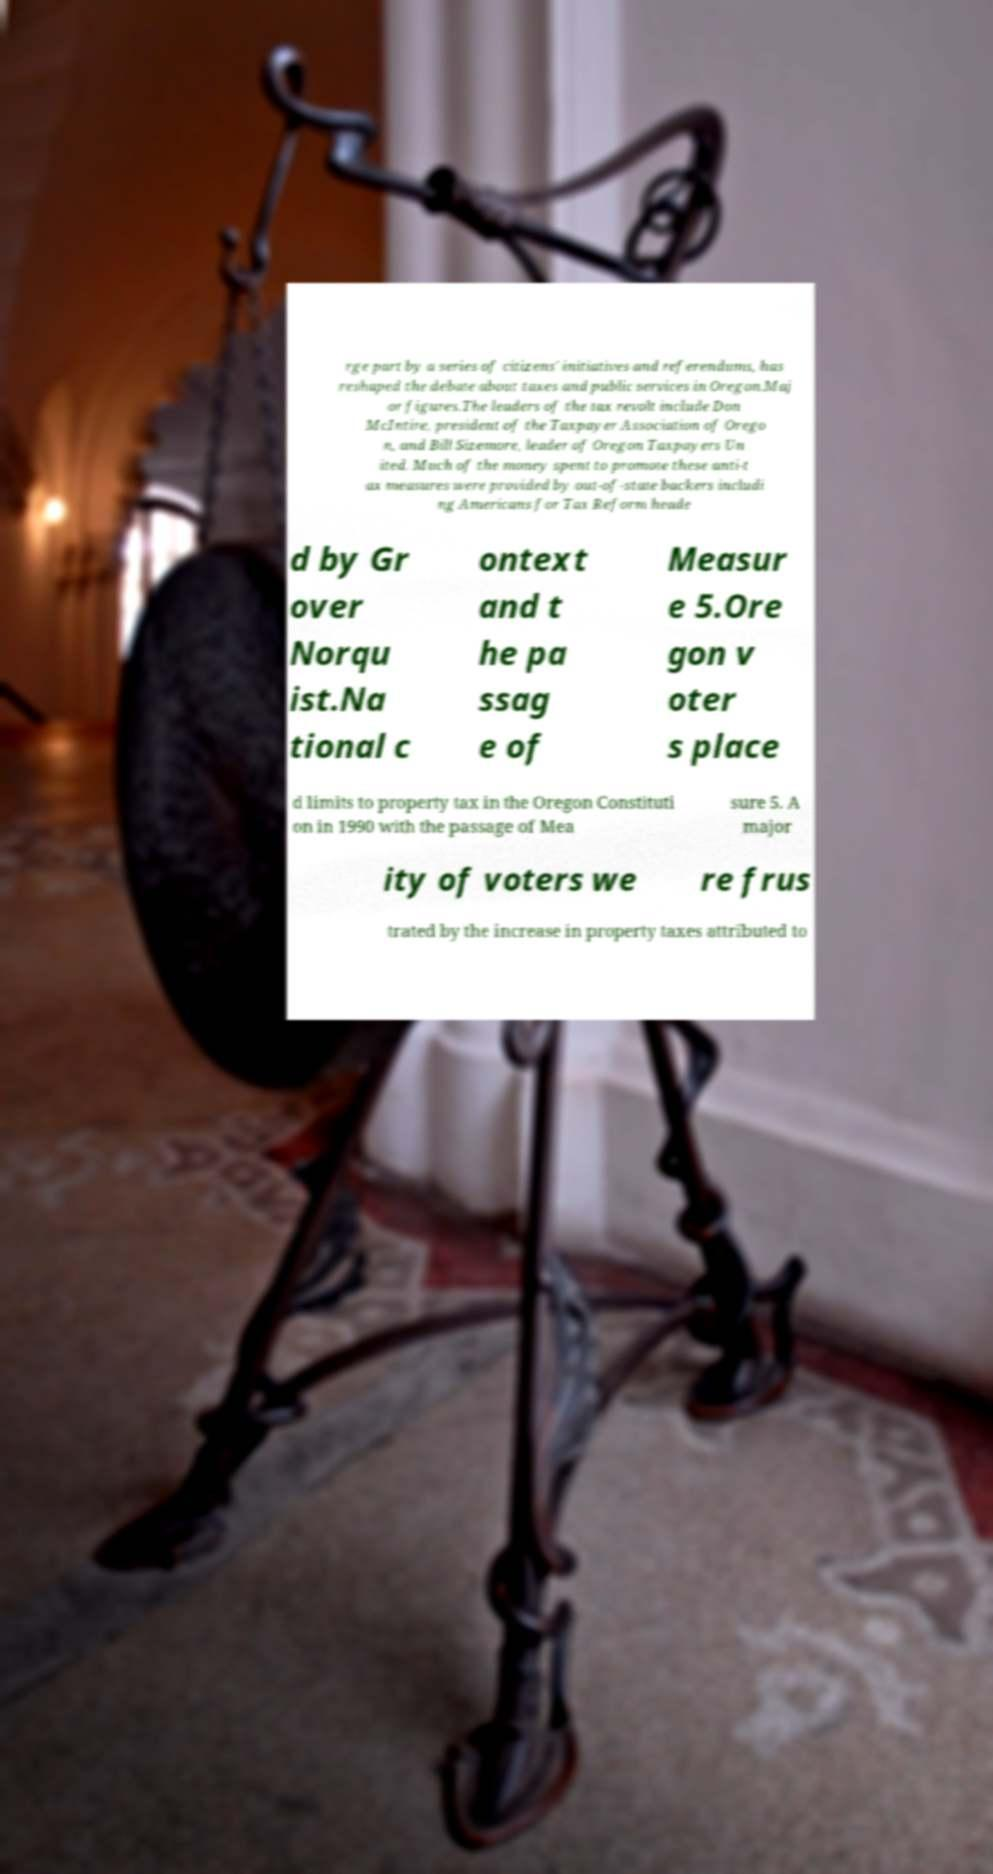Can you read and provide the text displayed in the image?This photo seems to have some interesting text. Can you extract and type it out for me? rge part by a series of citizens' initiatives and referendums, has reshaped the debate about taxes and public services in Oregon.Maj or figures.The leaders of the tax revolt include Don McIntire, president of the Taxpayer Association of Orego n, and Bill Sizemore, leader of Oregon Taxpayers Un ited. Much of the money spent to promote these anti-t ax measures were provided by out-of-state backers includi ng Americans for Tax Reform heade d by Gr over Norqu ist.Na tional c ontext and t he pa ssag e of Measur e 5.Ore gon v oter s place d limits to property tax in the Oregon Constituti on in 1990 with the passage of Mea sure 5. A major ity of voters we re frus trated by the increase in property taxes attributed to 